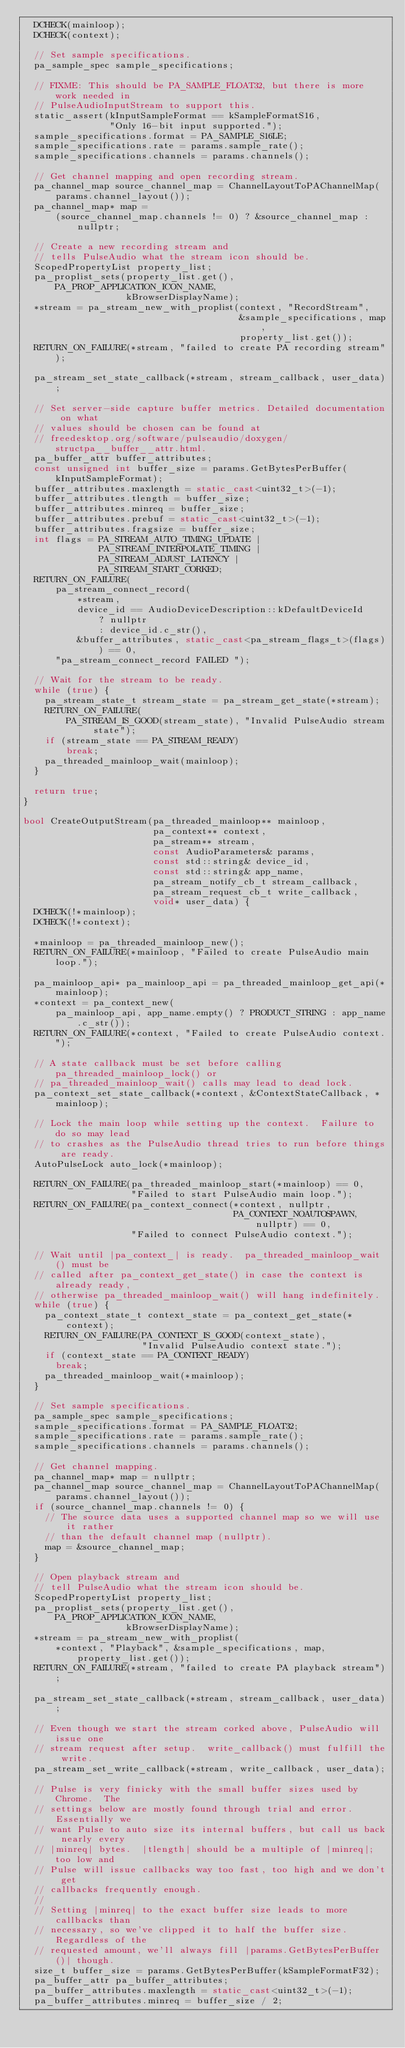Convert code to text. <code><loc_0><loc_0><loc_500><loc_500><_C++_>  DCHECK(mainloop);
  DCHECK(context);

  // Set sample specifications.
  pa_sample_spec sample_specifications;

  // FIXME: This should be PA_SAMPLE_FLOAT32, but there is more work needed in
  // PulseAudioInputStream to support this.
  static_assert(kInputSampleFormat == kSampleFormatS16,
                "Only 16-bit input supported.");
  sample_specifications.format = PA_SAMPLE_S16LE;
  sample_specifications.rate = params.sample_rate();
  sample_specifications.channels = params.channels();

  // Get channel mapping and open recording stream.
  pa_channel_map source_channel_map = ChannelLayoutToPAChannelMap(
      params.channel_layout());
  pa_channel_map* map =
      (source_channel_map.channels != 0) ? &source_channel_map : nullptr;

  // Create a new recording stream and
  // tells PulseAudio what the stream icon should be.
  ScopedPropertyList property_list;
  pa_proplist_sets(property_list.get(), PA_PROP_APPLICATION_ICON_NAME,
                   kBrowserDisplayName);
  *stream = pa_stream_new_with_proplist(context, "RecordStream",
                                        &sample_specifications, map,
                                        property_list.get());
  RETURN_ON_FAILURE(*stream, "failed to create PA recording stream");

  pa_stream_set_state_callback(*stream, stream_callback, user_data);

  // Set server-side capture buffer metrics. Detailed documentation on what
  // values should be chosen can be found at
  // freedesktop.org/software/pulseaudio/doxygen/structpa__buffer__attr.html.
  pa_buffer_attr buffer_attributes;
  const unsigned int buffer_size = params.GetBytesPerBuffer(kInputSampleFormat);
  buffer_attributes.maxlength = static_cast<uint32_t>(-1);
  buffer_attributes.tlength = buffer_size;
  buffer_attributes.minreq = buffer_size;
  buffer_attributes.prebuf = static_cast<uint32_t>(-1);
  buffer_attributes.fragsize = buffer_size;
  int flags = PA_STREAM_AUTO_TIMING_UPDATE |
              PA_STREAM_INTERPOLATE_TIMING |
              PA_STREAM_ADJUST_LATENCY |
              PA_STREAM_START_CORKED;
  RETURN_ON_FAILURE(
      pa_stream_connect_record(
          *stream,
          device_id == AudioDeviceDescription::kDefaultDeviceId
              ? nullptr
              : device_id.c_str(),
          &buffer_attributes, static_cast<pa_stream_flags_t>(flags)) == 0,
      "pa_stream_connect_record FAILED ");

  // Wait for the stream to be ready.
  while (true) {
    pa_stream_state_t stream_state = pa_stream_get_state(*stream);
    RETURN_ON_FAILURE(
        PA_STREAM_IS_GOOD(stream_state), "Invalid PulseAudio stream state");
    if (stream_state == PA_STREAM_READY)
        break;
    pa_threaded_mainloop_wait(mainloop);
  }

  return true;
}

bool CreateOutputStream(pa_threaded_mainloop** mainloop,
                        pa_context** context,
                        pa_stream** stream,
                        const AudioParameters& params,
                        const std::string& device_id,
                        const std::string& app_name,
                        pa_stream_notify_cb_t stream_callback,
                        pa_stream_request_cb_t write_callback,
                        void* user_data) {
  DCHECK(!*mainloop);
  DCHECK(!*context);

  *mainloop = pa_threaded_mainloop_new();
  RETURN_ON_FAILURE(*mainloop, "Failed to create PulseAudio main loop.");

  pa_mainloop_api* pa_mainloop_api = pa_threaded_mainloop_get_api(*mainloop);
  *context = pa_context_new(
      pa_mainloop_api, app_name.empty() ? PRODUCT_STRING : app_name.c_str());
  RETURN_ON_FAILURE(*context, "Failed to create PulseAudio context.");

  // A state callback must be set before calling pa_threaded_mainloop_lock() or
  // pa_threaded_mainloop_wait() calls may lead to dead lock.
  pa_context_set_state_callback(*context, &ContextStateCallback, *mainloop);

  // Lock the main loop while setting up the context.  Failure to do so may lead
  // to crashes as the PulseAudio thread tries to run before things are ready.
  AutoPulseLock auto_lock(*mainloop);

  RETURN_ON_FAILURE(pa_threaded_mainloop_start(*mainloop) == 0,
                    "Failed to start PulseAudio main loop.");
  RETURN_ON_FAILURE(pa_context_connect(*context, nullptr,
                                       PA_CONTEXT_NOAUTOSPAWN, nullptr) == 0,
                    "Failed to connect PulseAudio context.");

  // Wait until |pa_context_| is ready.  pa_threaded_mainloop_wait() must be
  // called after pa_context_get_state() in case the context is already ready,
  // otherwise pa_threaded_mainloop_wait() will hang indefinitely.
  while (true) {
    pa_context_state_t context_state = pa_context_get_state(*context);
    RETURN_ON_FAILURE(PA_CONTEXT_IS_GOOD(context_state),
                      "Invalid PulseAudio context state.");
    if (context_state == PA_CONTEXT_READY)
      break;
    pa_threaded_mainloop_wait(*mainloop);
  }

  // Set sample specifications.
  pa_sample_spec sample_specifications;
  sample_specifications.format = PA_SAMPLE_FLOAT32;
  sample_specifications.rate = params.sample_rate();
  sample_specifications.channels = params.channels();

  // Get channel mapping.
  pa_channel_map* map = nullptr;
  pa_channel_map source_channel_map = ChannelLayoutToPAChannelMap(
      params.channel_layout());
  if (source_channel_map.channels != 0) {
    // The source data uses a supported channel map so we will use it rather
    // than the default channel map (nullptr).
    map = &source_channel_map;
  }

  // Open playback stream and
  // tell PulseAudio what the stream icon should be.
  ScopedPropertyList property_list;
  pa_proplist_sets(property_list.get(), PA_PROP_APPLICATION_ICON_NAME,
                   kBrowserDisplayName);
  *stream = pa_stream_new_with_proplist(
      *context, "Playback", &sample_specifications, map, property_list.get());
  RETURN_ON_FAILURE(*stream, "failed to create PA playback stream");

  pa_stream_set_state_callback(*stream, stream_callback, user_data);

  // Even though we start the stream corked above, PulseAudio will issue one
  // stream request after setup.  write_callback() must fulfill the write.
  pa_stream_set_write_callback(*stream, write_callback, user_data);

  // Pulse is very finicky with the small buffer sizes used by Chrome.  The
  // settings below are mostly found through trial and error.  Essentially we
  // want Pulse to auto size its internal buffers, but call us back nearly every
  // |minreq| bytes.  |tlength| should be a multiple of |minreq|; too low and
  // Pulse will issue callbacks way too fast, too high and we don't get
  // callbacks frequently enough.
  //
  // Setting |minreq| to the exact buffer size leads to more callbacks than
  // necessary, so we've clipped it to half the buffer size.  Regardless of the
  // requested amount, we'll always fill |params.GetBytesPerBuffer()| though.
  size_t buffer_size = params.GetBytesPerBuffer(kSampleFormatF32);
  pa_buffer_attr pa_buffer_attributes;
  pa_buffer_attributes.maxlength = static_cast<uint32_t>(-1);
  pa_buffer_attributes.minreq = buffer_size / 2;</code> 